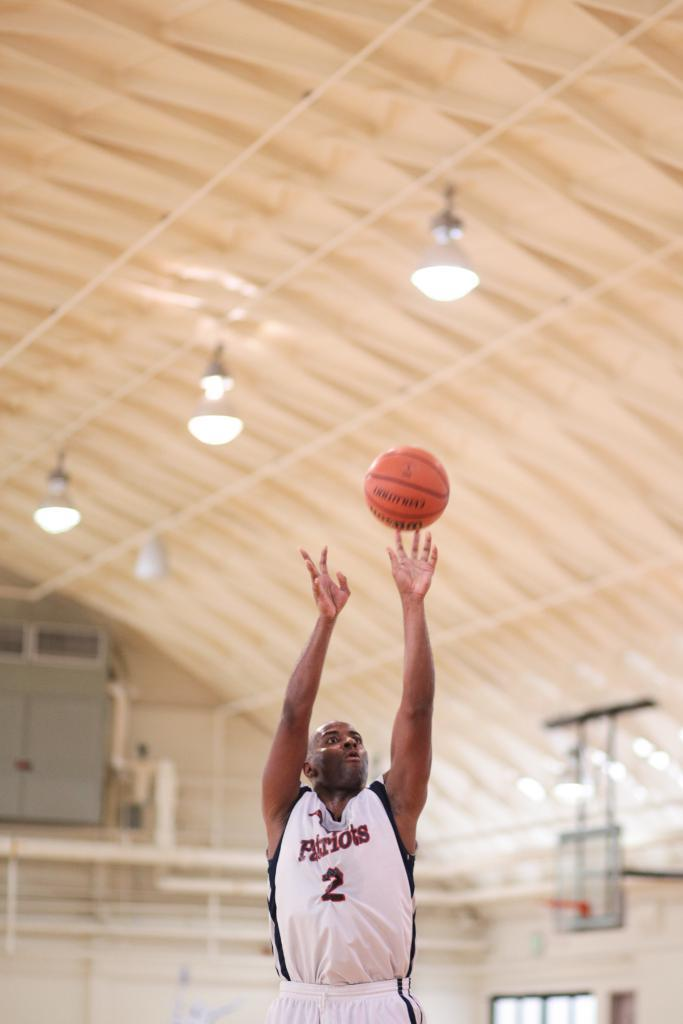What is the main subject of the image? There is a man standing in the image. Where is the man standing? The man is standing on the floor. What other object can be seen in the image? There is a ball in the image. What can be seen in the background of the image? There are cupboards, a shed, and electric lights in the background of the image. What type of frog can be seen swimming in the image? There is no frog present in the image; it features a man standing, a ball, and various background elements. What kind of jellyfish is visible in the image? There is no jellyfish present in the image. 